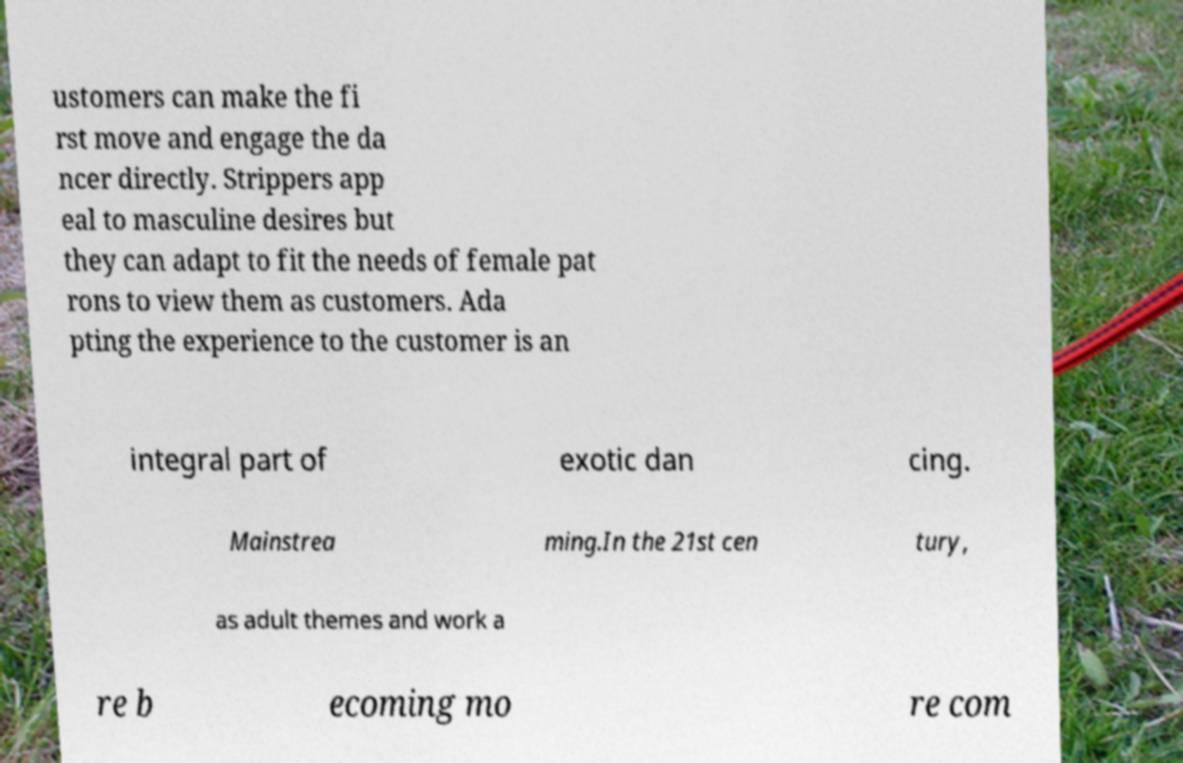Can you read and provide the text displayed in the image?This photo seems to have some interesting text. Can you extract and type it out for me? ustomers can make the fi rst move and engage the da ncer directly. Strippers app eal to masculine desires but they can adapt to fit the needs of female pat rons to view them as customers. Ada pting the experience to the customer is an integral part of exotic dan cing. Mainstrea ming.In the 21st cen tury, as adult themes and work a re b ecoming mo re com 